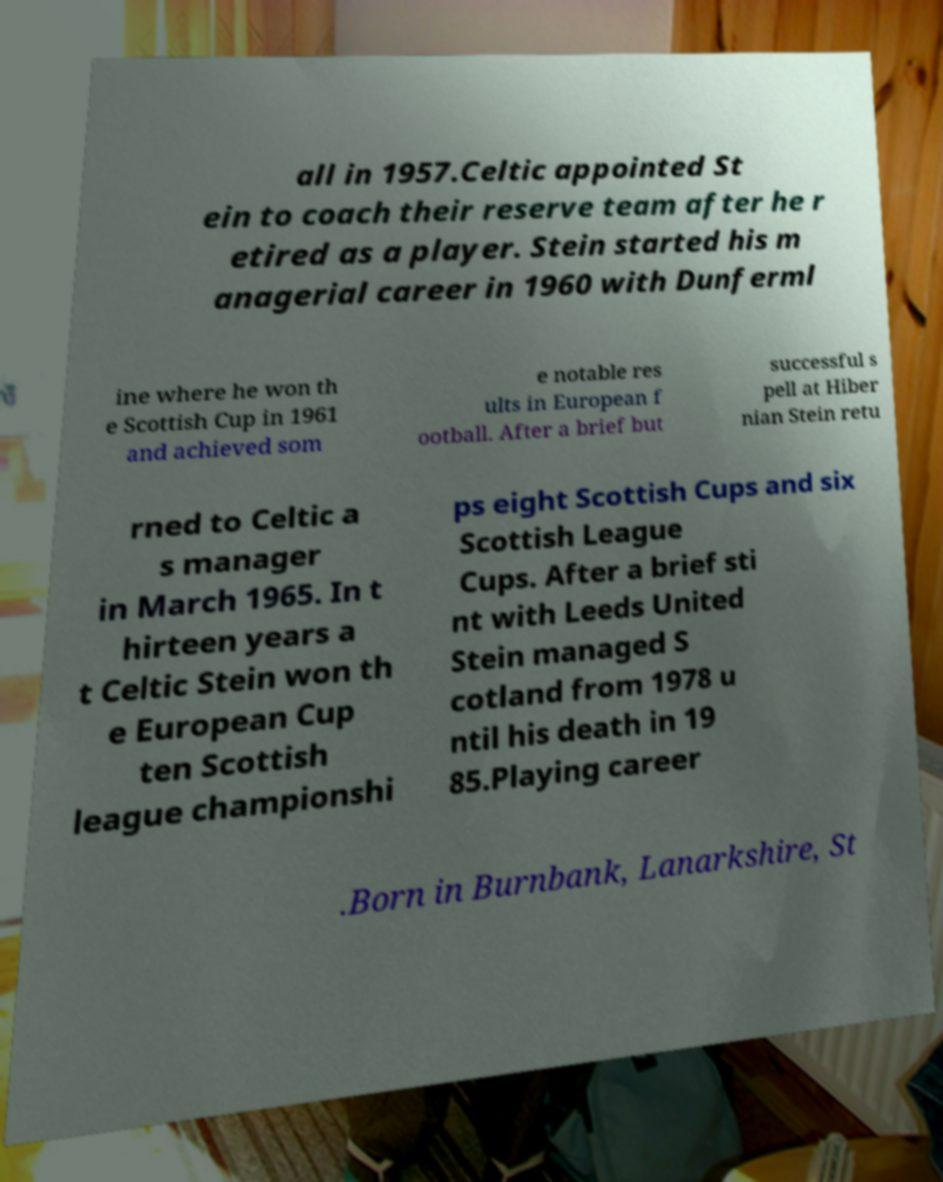Can you accurately transcribe the text from the provided image for me? all in 1957.Celtic appointed St ein to coach their reserve team after he r etired as a player. Stein started his m anagerial career in 1960 with Dunferml ine where he won th e Scottish Cup in 1961 and achieved som e notable res ults in European f ootball. After a brief but successful s pell at Hiber nian Stein retu rned to Celtic a s manager in March 1965. In t hirteen years a t Celtic Stein won th e European Cup ten Scottish league championshi ps eight Scottish Cups and six Scottish League Cups. After a brief sti nt with Leeds United Stein managed S cotland from 1978 u ntil his death in 19 85.Playing career .Born in Burnbank, Lanarkshire, St 